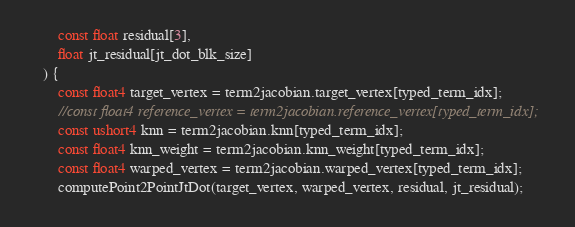Convert code to text. <code><loc_0><loc_0><loc_500><loc_500><_Cuda_>		const float residual[3],
		float jt_residual[jt_dot_blk_size]
	) {
		const float4 target_vertex = term2jacobian.target_vertex[typed_term_idx];
		//const float4 reference_vertex = term2jacobian.reference_vertex[typed_term_idx];
		const ushort4 knn = term2jacobian.knn[typed_term_idx];
		const float4 knn_weight = term2jacobian.knn_weight[typed_term_idx];
		const float4 warped_vertex = term2jacobian.warped_vertex[typed_term_idx];
		computePoint2PointJtDot(target_vertex, warped_vertex, residual, jt_residual);
</code> 